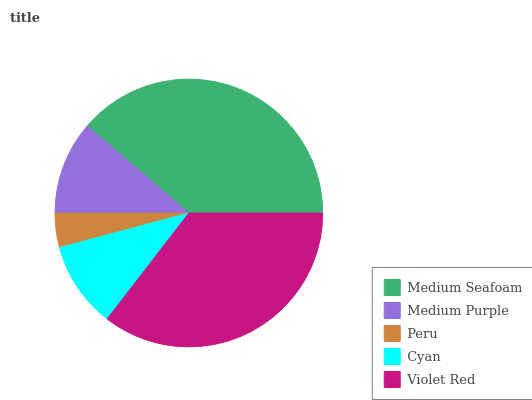Is Peru the minimum?
Answer yes or no. Yes. Is Medium Seafoam the maximum?
Answer yes or no. Yes. Is Medium Purple the minimum?
Answer yes or no. No. Is Medium Purple the maximum?
Answer yes or no. No. Is Medium Seafoam greater than Medium Purple?
Answer yes or no. Yes. Is Medium Purple less than Medium Seafoam?
Answer yes or no. Yes. Is Medium Purple greater than Medium Seafoam?
Answer yes or no. No. Is Medium Seafoam less than Medium Purple?
Answer yes or no. No. Is Medium Purple the high median?
Answer yes or no. Yes. Is Medium Purple the low median?
Answer yes or no. Yes. Is Violet Red the high median?
Answer yes or no. No. Is Violet Red the low median?
Answer yes or no. No. 